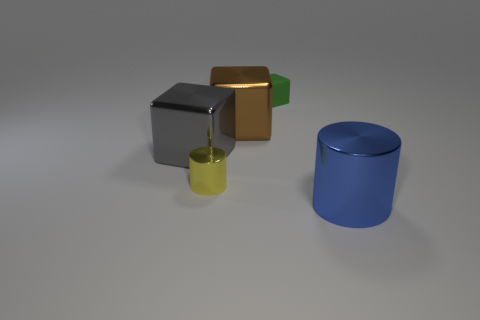Add 1 big metallic things. How many objects exist? 6 Subtract all cylinders. How many objects are left? 3 Subtract 0 red balls. How many objects are left? 5 Subtract all large brown cubes. Subtract all large things. How many objects are left? 1 Add 4 small cylinders. How many small cylinders are left? 5 Add 2 small green blocks. How many small green blocks exist? 3 